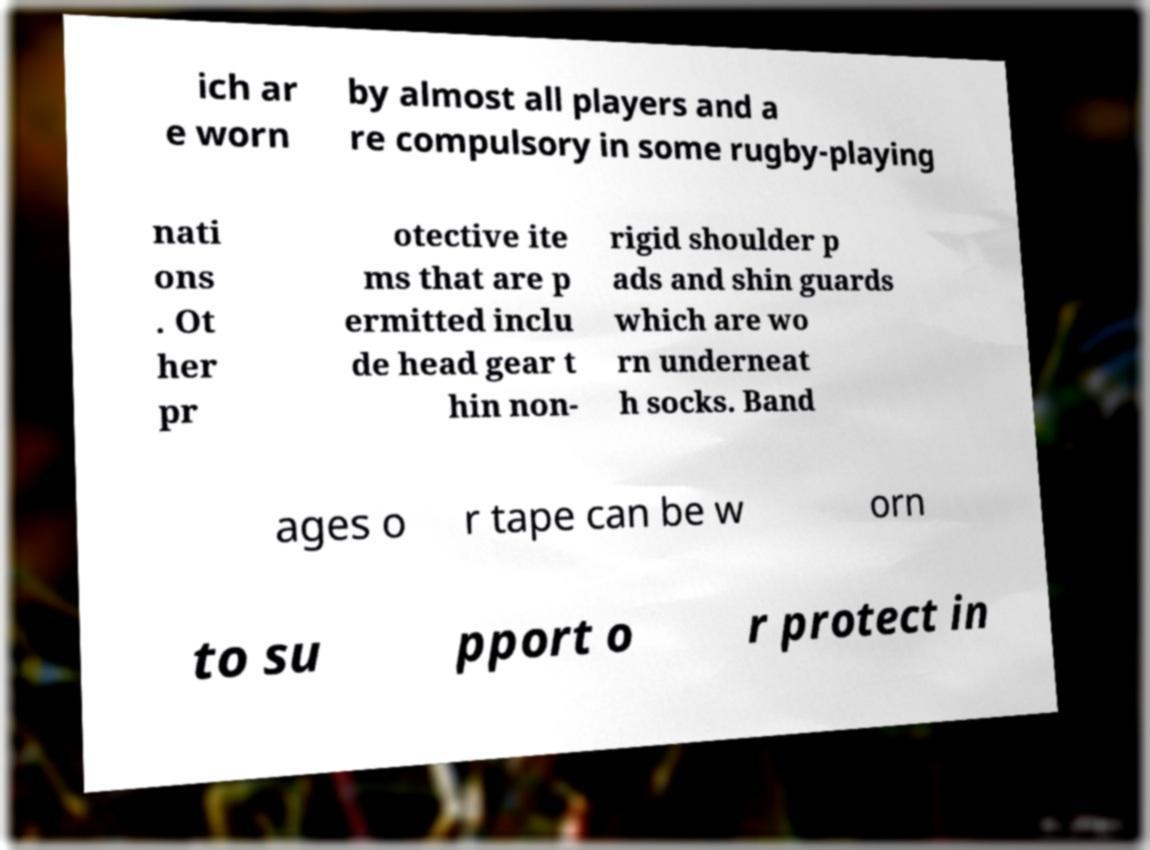What messages or text are displayed in this image? I need them in a readable, typed format. ich ar e worn by almost all players and a re compulsory in some rugby-playing nati ons . Ot her pr otective ite ms that are p ermitted inclu de head gear t hin non- rigid shoulder p ads and shin guards which are wo rn underneat h socks. Band ages o r tape can be w orn to su pport o r protect in 